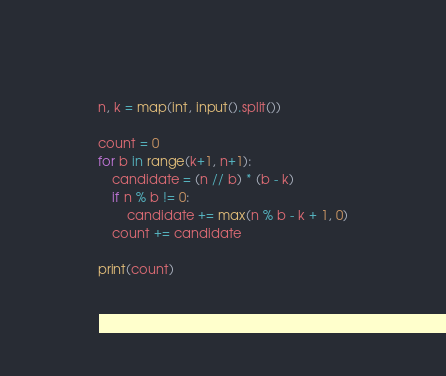<code> <loc_0><loc_0><loc_500><loc_500><_Python_>n, k = map(int, input().split())

count = 0
for b in range(k+1, n+1):
    candidate = (n // b) * (b - k)
    if n % b != 0:
        candidate += max(n % b - k + 1, 0)
    count += candidate

print(count)</code> 